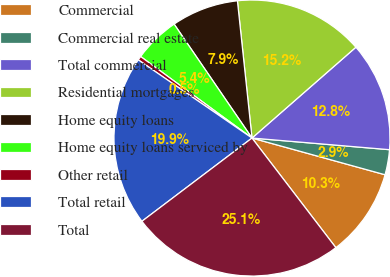<chart> <loc_0><loc_0><loc_500><loc_500><pie_chart><fcel>Commercial<fcel>Commercial real estate<fcel>Total commercial<fcel>Residential mortgages<fcel>Home equity loans<fcel>Home equity loans serviced by<fcel>Other retail<fcel>Total retail<fcel>Total<nl><fcel>10.32%<fcel>2.94%<fcel>12.78%<fcel>15.25%<fcel>7.86%<fcel>5.4%<fcel>0.47%<fcel>19.89%<fcel>25.09%<nl></chart> 